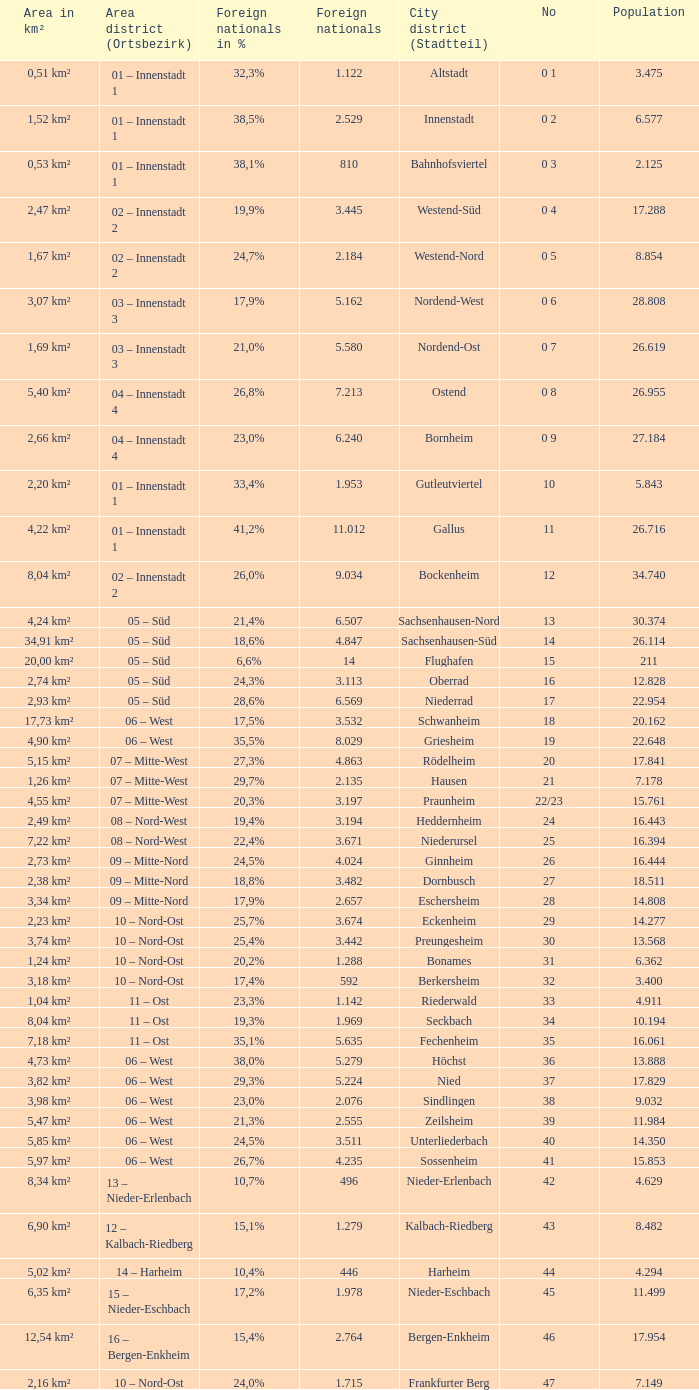How many foreigners in percentage terms had a population of 4.911? 1.0. 